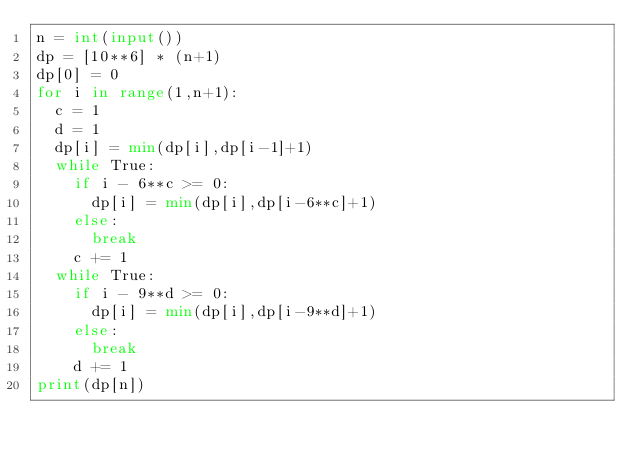<code> <loc_0><loc_0><loc_500><loc_500><_Python_>n = int(input())
dp = [10**6] * (n+1)
dp[0] = 0
for i in range(1,n+1):
  c = 1
  d = 1
  dp[i] = min(dp[i],dp[i-1]+1)
  while True:
    if i - 6**c >= 0:
      dp[i] = min(dp[i],dp[i-6**c]+1)
    else:
      break
    c += 1
  while True:
    if i - 9**d >= 0:
      dp[i] = min(dp[i],dp[i-9**d]+1)
    else:
      break
    d += 1
print(dp[n])</code> 